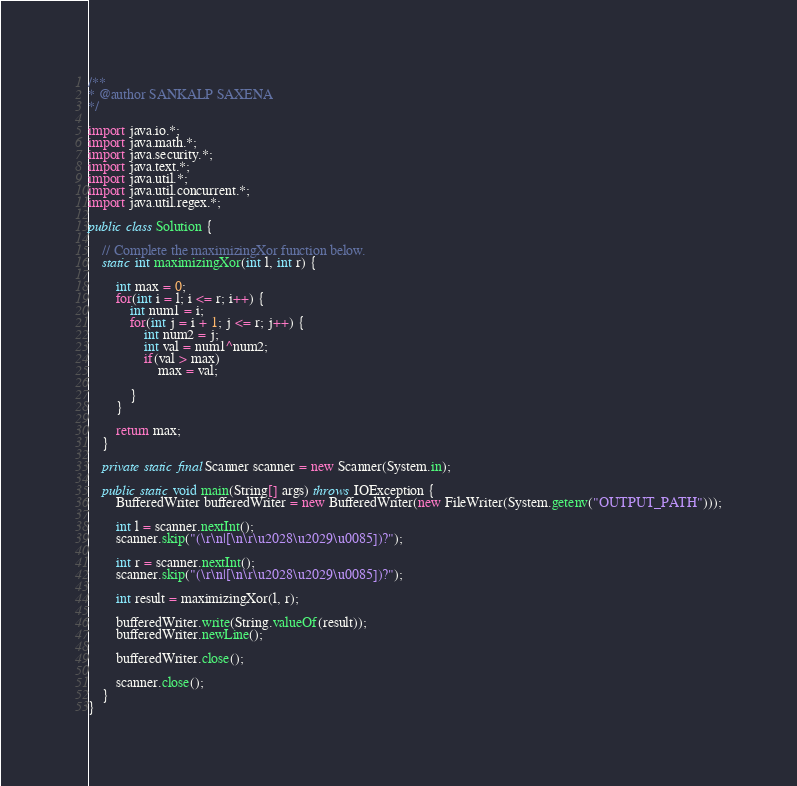Convert code to text. <code><loc_0><loc_0><loc_500><loc_500><_Java_>/**  
* @author SANKALP SAXENA  
*/

import java.io.*;
import java.math.*;
import java.security.*;
import java.text.*;
import java.util.*;
import java.util.concurrent.*;
import java.util.regex.*;

public class Solution {

    // Complete the maximizingXor function below.
    static int maximizingXor(int l, int r) {

        int max = 0;
        for(int i = l; i <= r; i++) {
            int num1 = i;
            for(int j = i + 1; j <= r; j++) {
                int num2 = j;
                int val = num1^num2;
                if(val > max)
                    max = val;

            }
        }

        return max;
    }

    private static final Scanner scanner = new Scanner(System.in);

    public static void main(String[] args) throws IOException {
        BufferedWriter bufferedWriter = new BufferedWriter(new FileWriter(System.getenv("OUTPUT_PATH")));

        int l = scanner.nextInt();
        scanner.skip("(\r\n|[\n\r\u2028\u2029\u0085])?");

        int r = scanner.nextInt();
        scanner.skip("(\r\n|[\n\r\u2028\u2029\u0085])?");

        int result = maximizingXor(l, r);

        bufferedWriter.write(String.valueOf(result));
        bufferedWriter.newLine();

        bufferedWriter.close();

        scanner.close();
    }
}
</code> 